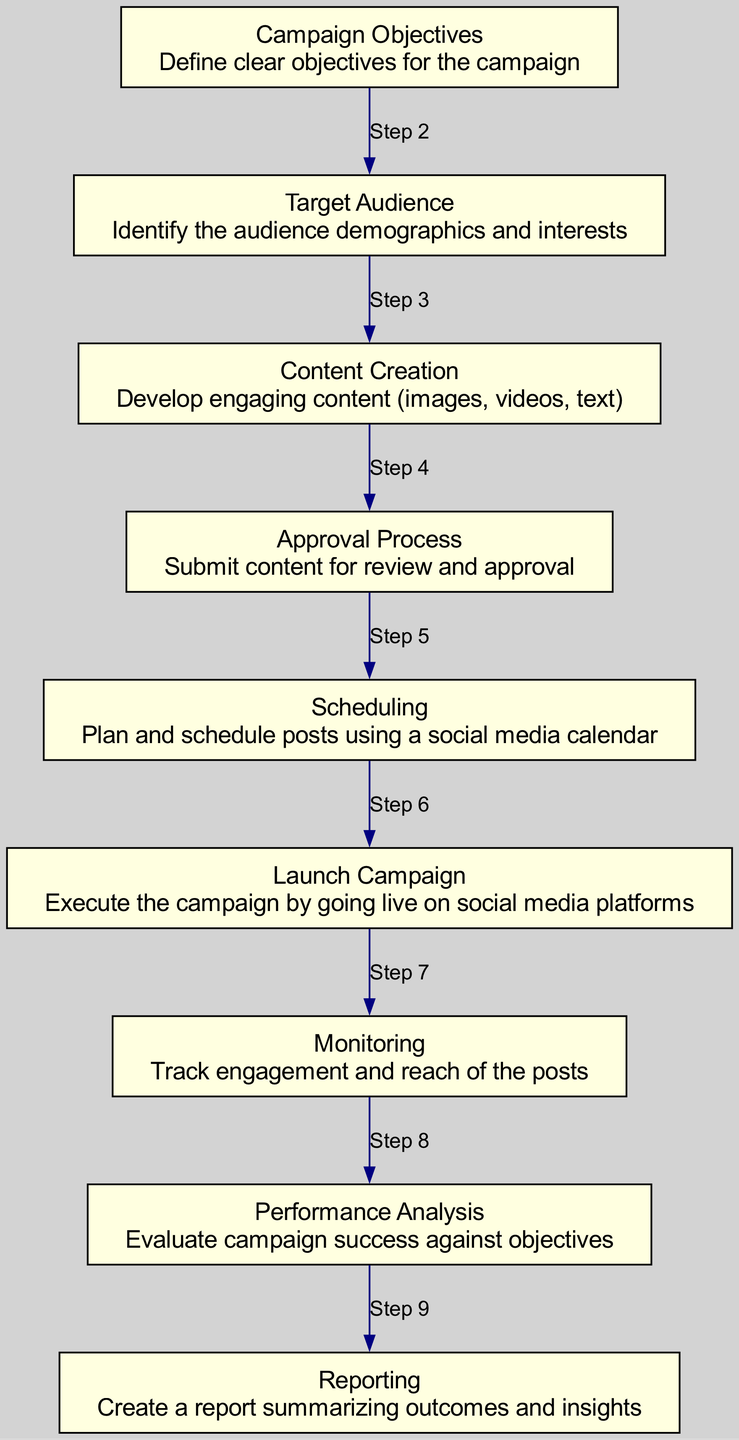What is the first step in the campaign planning workflow? The first step in the workflow is "Define clear objectives for the campaign." This is indicated as the initial node in the sequence diagram, where the workflow begins.
Answer: Define clear objectives for the campaign How many steps are there in the social media campaign planning workflow? The diagram contains nine distinct steps, each represented as a node, denoting the overall process from objectives to reporting.
Answer: Nine What action follows the Approval Process? The action that follows the Approval Process is "Plan and schedule posts using a social media calendar." This is seen as the next node connected by an edge in the sequence.
Answer: Plan and schedule posts using a social media calendar Which two nodes are directly connected by "Step 7"? "Monitoring" and "Performance Analysis" are the two nodes connected by "Step 7." This indicates the workflow progression from monitoring engagement to evaluating success.
Answer: Monitoring and Performance Analysis What is the last action in the campaign planning workflow? The last action is "Create a report summarizing outcomes and insights," marking the conclusion of the campaign planning process.
Answer: Create a report summarizing outcomes and insights In which step is content submitted for review? Content is submitted for review during the "Approval Process." This step specifically indicates the review stage before content is published.
Answer: Approval Process What does the scheduling step involve? The scheduling step involves "Plan and schedule posts using a social media calendar," indicating the arrangement of posts prior to going live.
Answer: Plan and schedule posts using a social media calendar Which step is directly before the Launch Campaign? The step directly before the Launch Campaign is "Scheduling," where the posts are arranged before the actual campaign execution.
Answer: Scheduling What relationship does "Performance Analysis" have with "Monitoring"? "Performance Analysis" directly follows "Monitoring," indicating that the analysis occurs after tracking engagement and reach.
Answer: Direct succession 